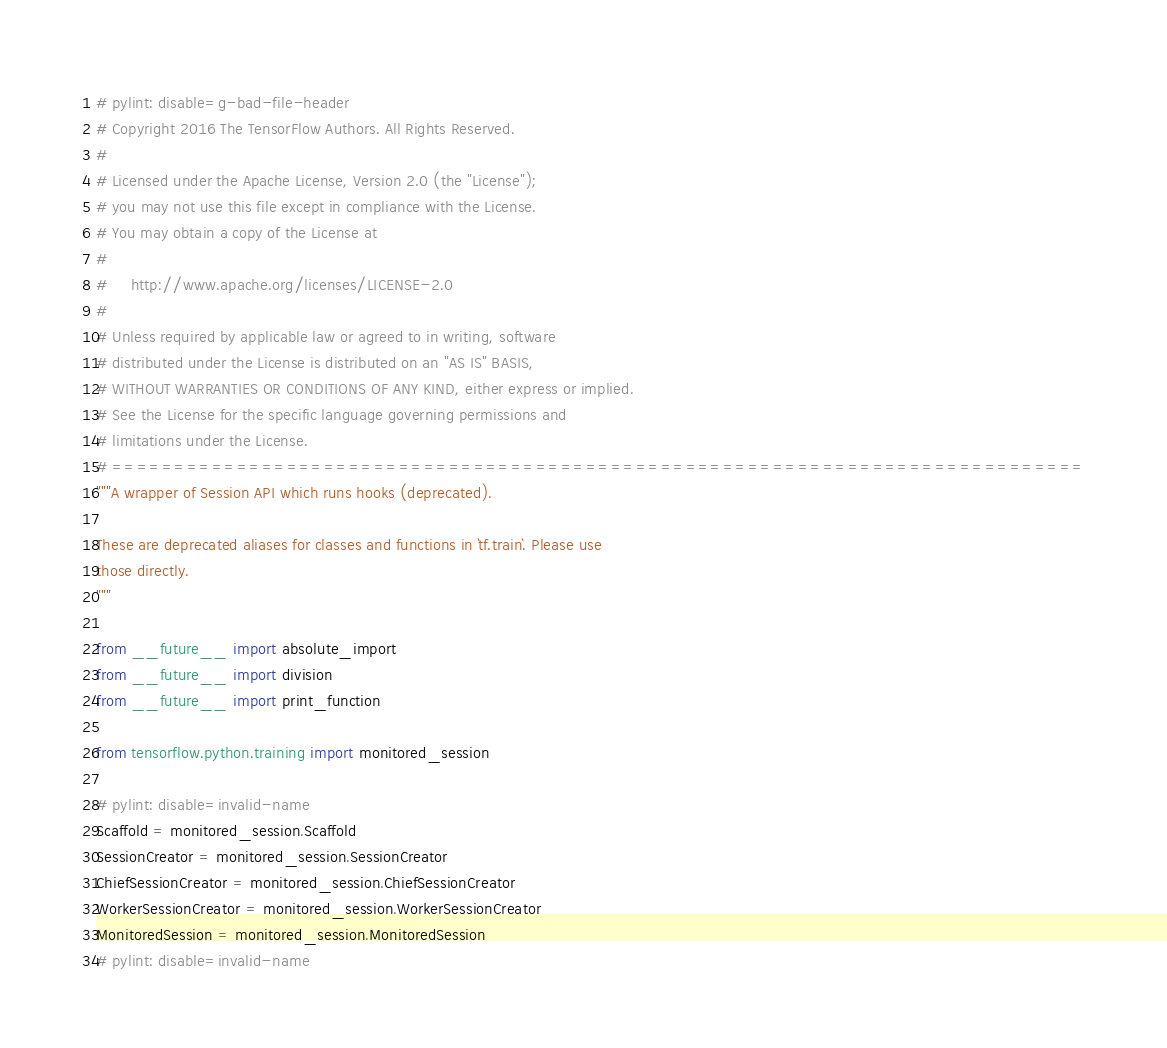Convert code to text. <code><loc_0><loc_0><loc_500><loc_500><_Python_># pylint: disable=g-bad-file-header
# Copyright 2016 The TensorFlow Authors. All Rights Reserved.
#
# Licensed under the Apache License, Version 2.0 (the "License");
# you may not use this file except in compliance with the License.
# You may obtain a copy of the License at
#
#     http://www.apache.org/licenses/LICENSE-2.0
#
# Unless required by applicable law or agreed to in writing, software
# distributed under the License is distributed on an "AS IS" BASIS,
# WITHOUT WARRANTIES OR CONDITIONS OF ANY KIND, either express or implied.
# See the License for the specific language governing permissions and
# limitations under the License.
# ==============================================================================
"""A wrapper of Session API which runs hooks (deprecated).

These are deprecated aliases for classes and functions in `tf.train`. Please use
those directly.
"""

from __future__ import absolute_import
from __future__ import division
from __future__ import print_function

from tensorflow.python.training import monitored_session

# pylint: disable=invalid-name
Scaffold = monitored_session.Scaffold
SessionCreator = monitored_session.SessionCreator
ChiefSessionCreator = monitored_session.ChiefSessionCreator
WorkerSessionCreator = monitored_session.WorkerSessionCreator
MonitoredSession = monitored_session.MonitoredSession
# pylint: disable=invalid-name
</code> 